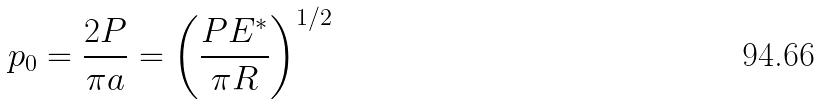<formula> <loc_0><loc_0><loc_500><loc_500>p _ { 0 } = \frac { 2 P } { \pi a } = \left ( \frac { P E ^ { * } } { \pi R } \right ) ^ { 1 / 2 }</formula> 